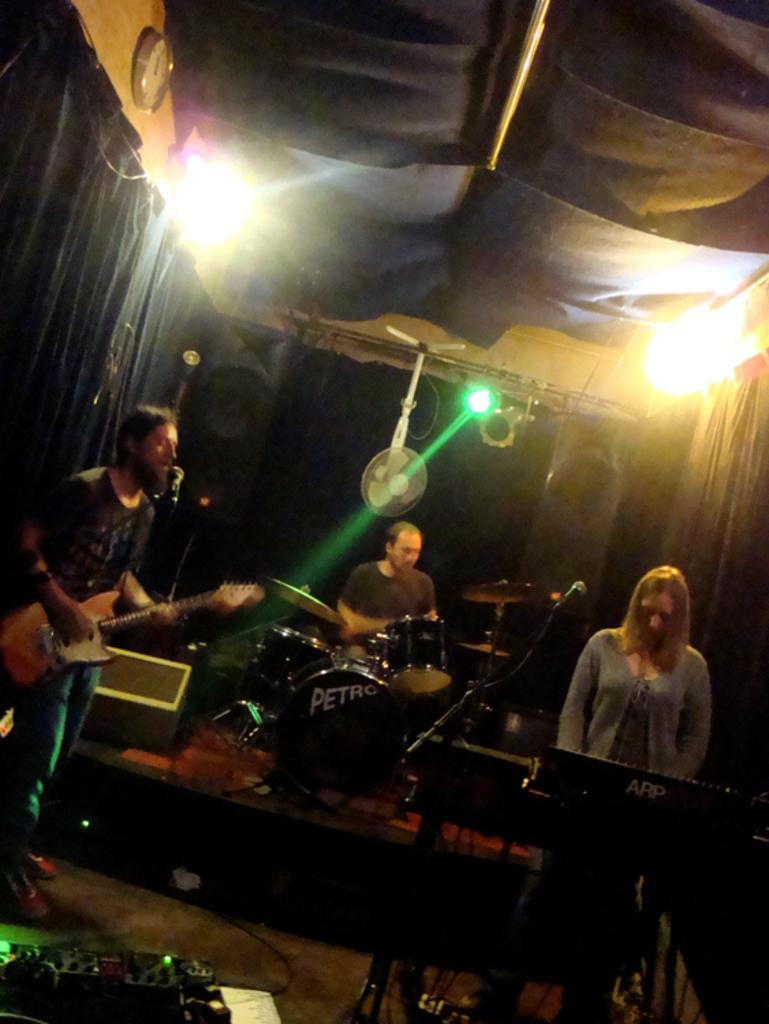What are the people in the image doing? The people in the image are playing music instruments. What can be seen in the image besides the people playing instruments? There are lights, a fan, curtains, and a clock attached to the wall on the left side of the image. What type of furniture is being used by the frog in the image? There is no frog present in the image, so it is not possible to determine what type of furniture a frog might be using. 